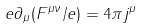Convert formula to latex. <formula><loc_0><loc_0><loc_500><loc_500>e \partial _ { \mu } ( F ^ { \mu \nu } / e ) = 4 \pi j ^ { \mu }</formula> 